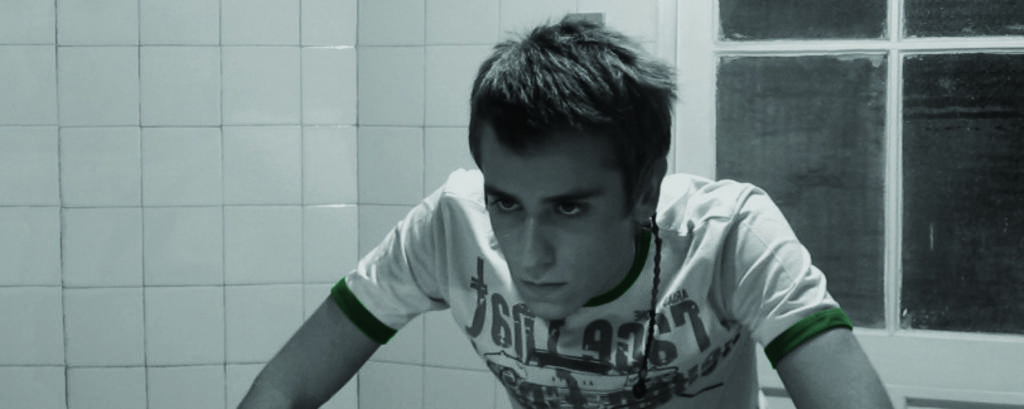Who is present in the image? There is a man in the image. What is the man wearing? The man is wearing a T-shirt. What type of window can be seen on the right side of the image? There is a glass window on the right side of the image. What material is the wall on the left side of the image made of? The wall on the left side of the image is made of marble. What type of toothpaste is the man using in the image? There is no toothpaste present in the image, and the man is not performing any activity that would involve toothpaste. 